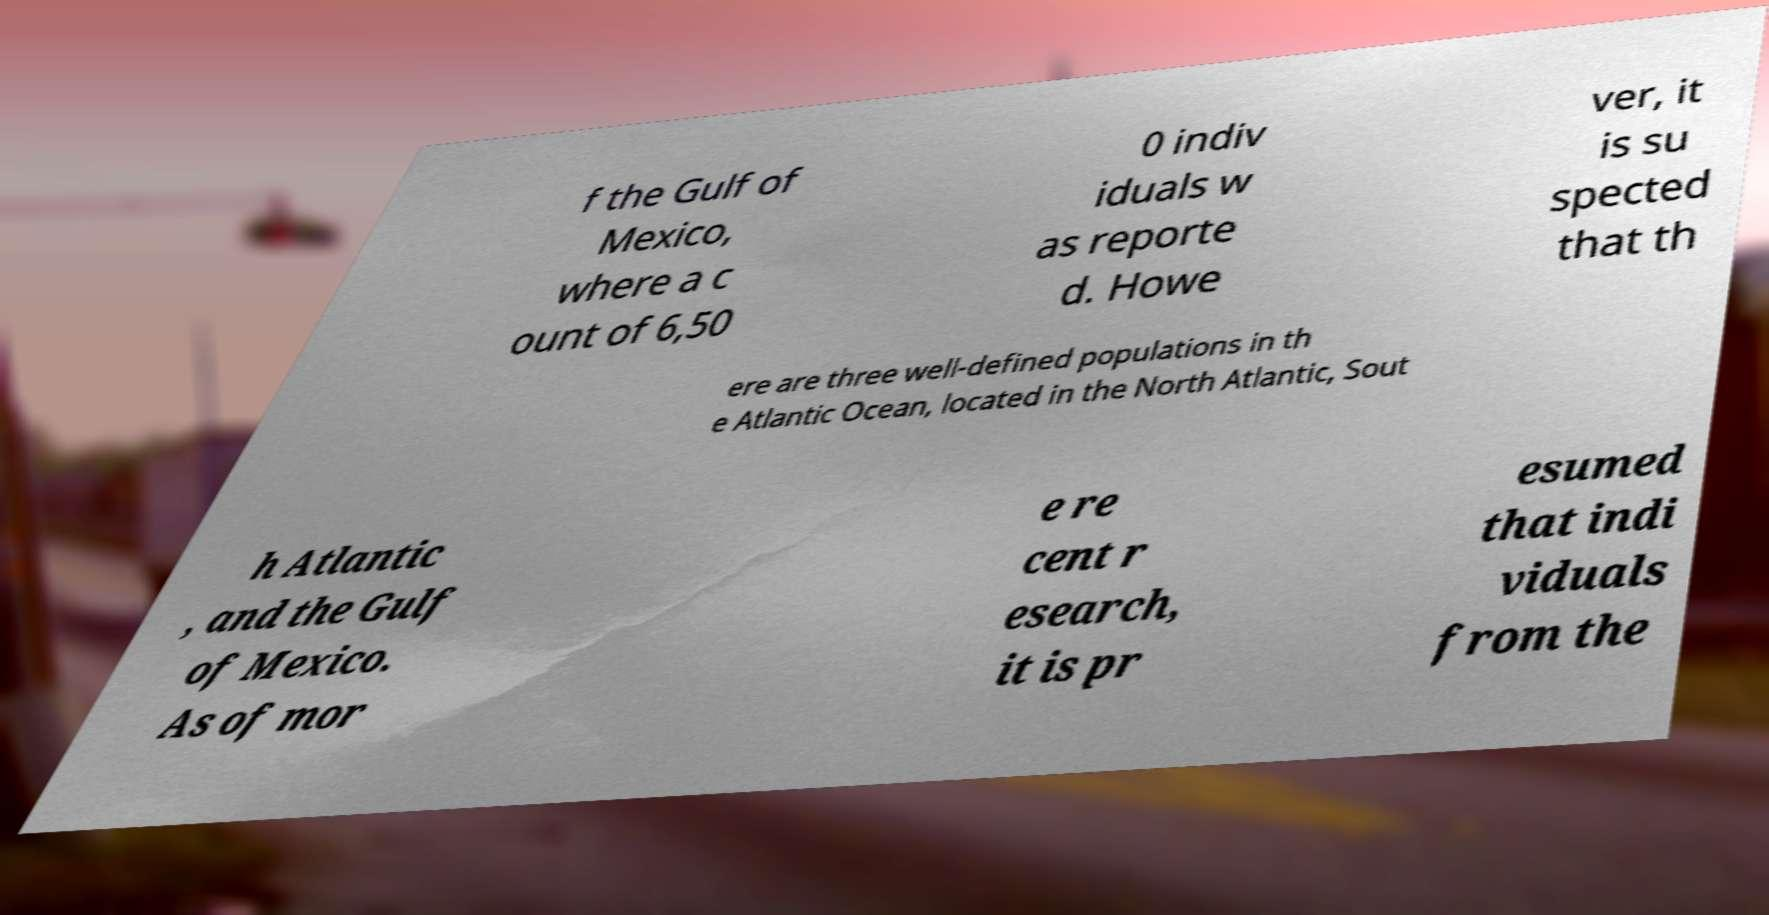Could you extract and type out the text from this image? f the Gulf of Mexico, where a c ount of 6,50 0 indiv iduals w as reporte d. Howe ver, it is su spected that th ere are three well-defined populations in th e Atlantic Ocean, located in the North Atlantic, Sout h Atlantic , and the Gulf of Mexico. As of mor e re cent r esearch, it is pr esumed that indi viduals from the 